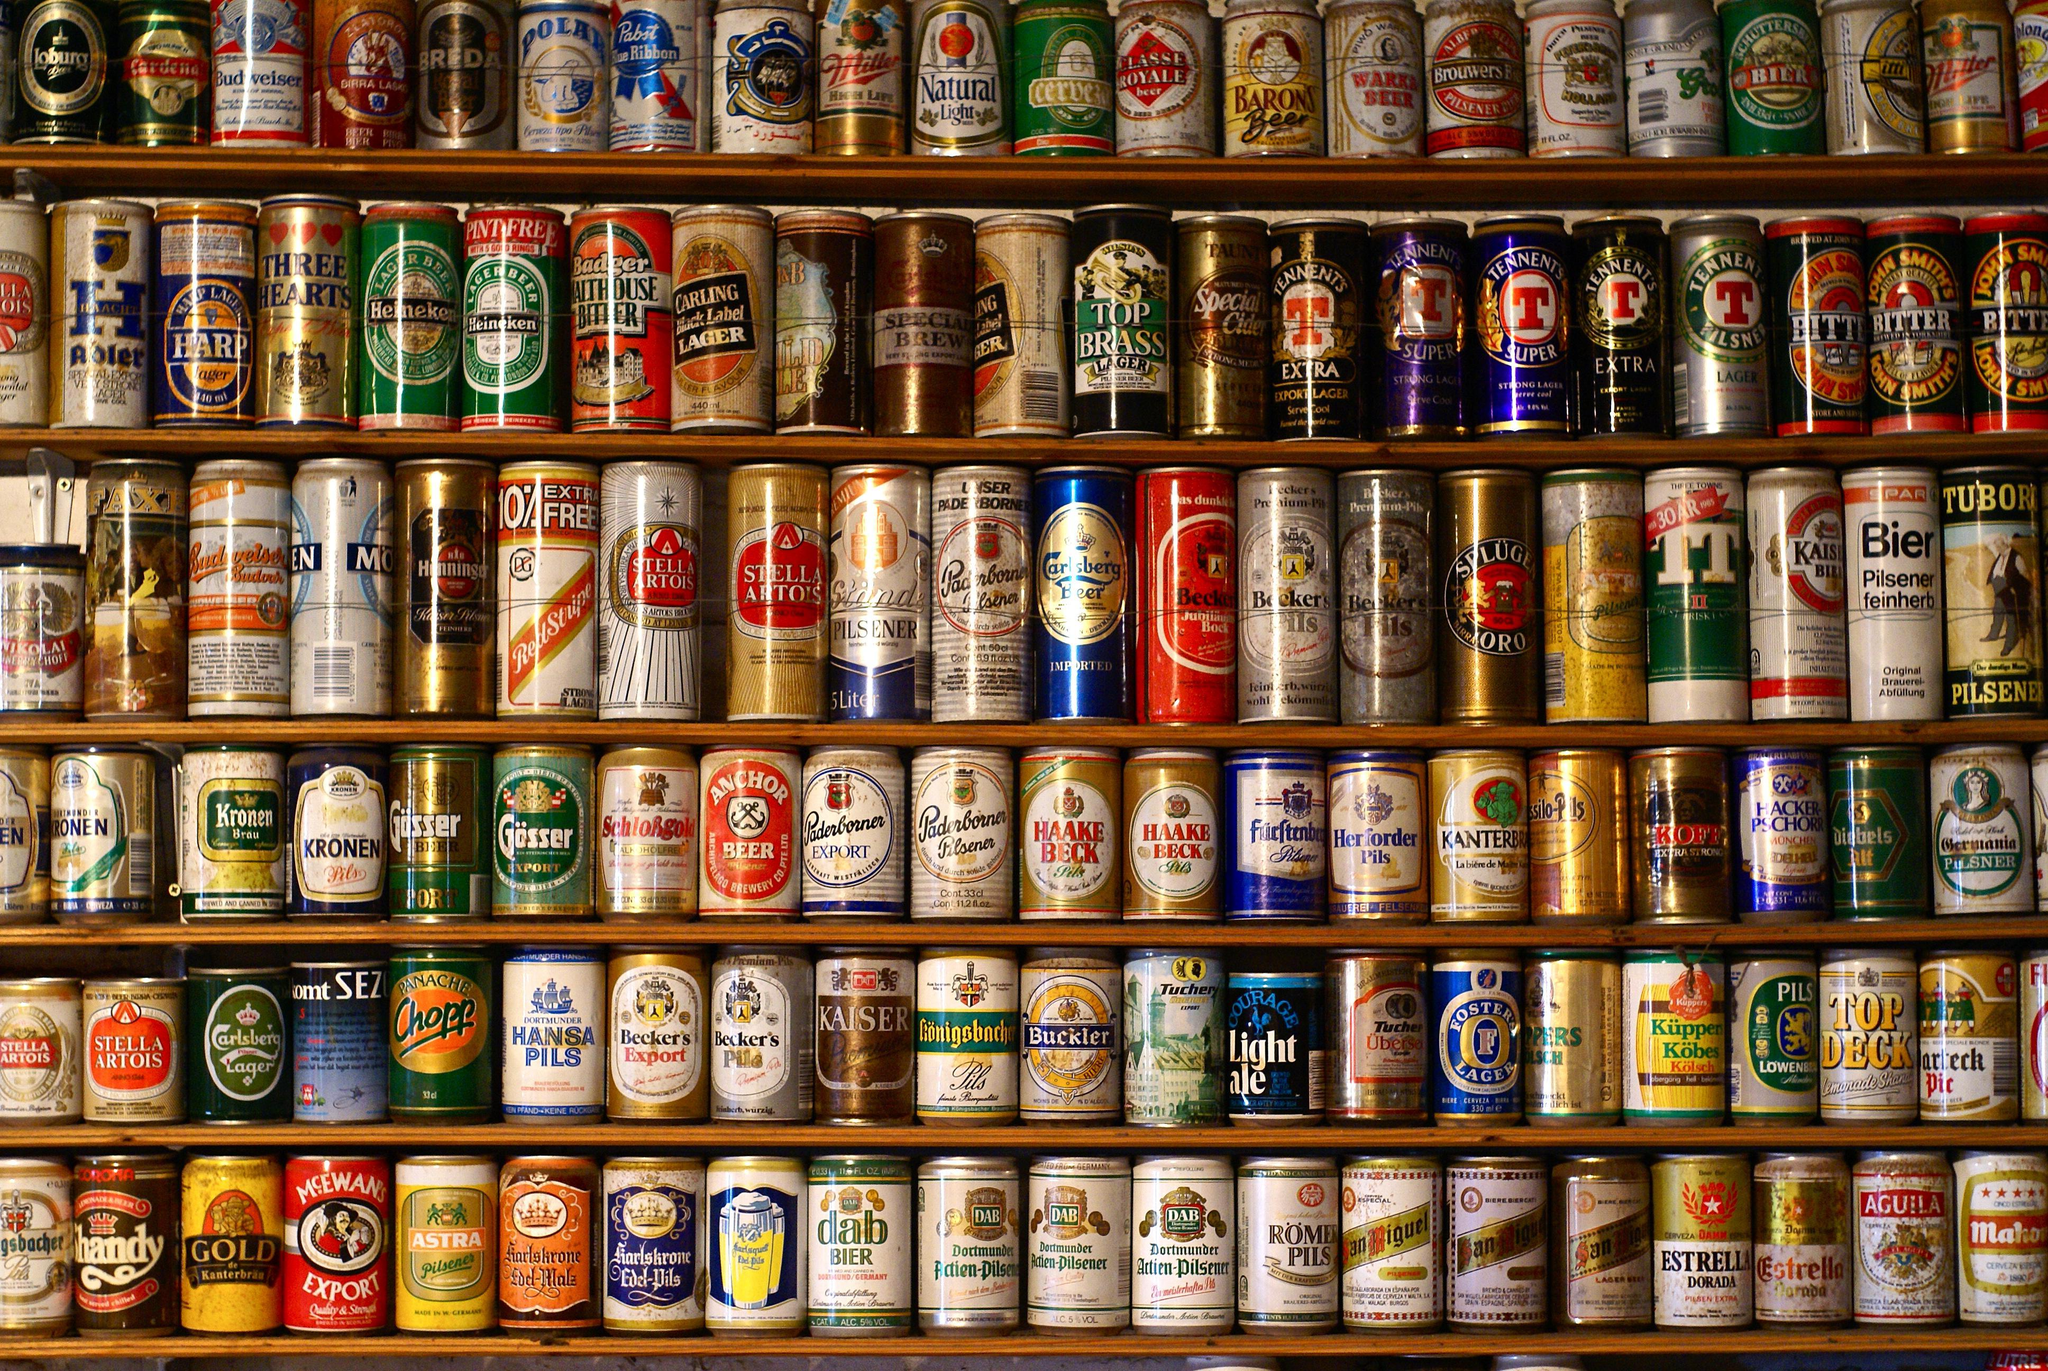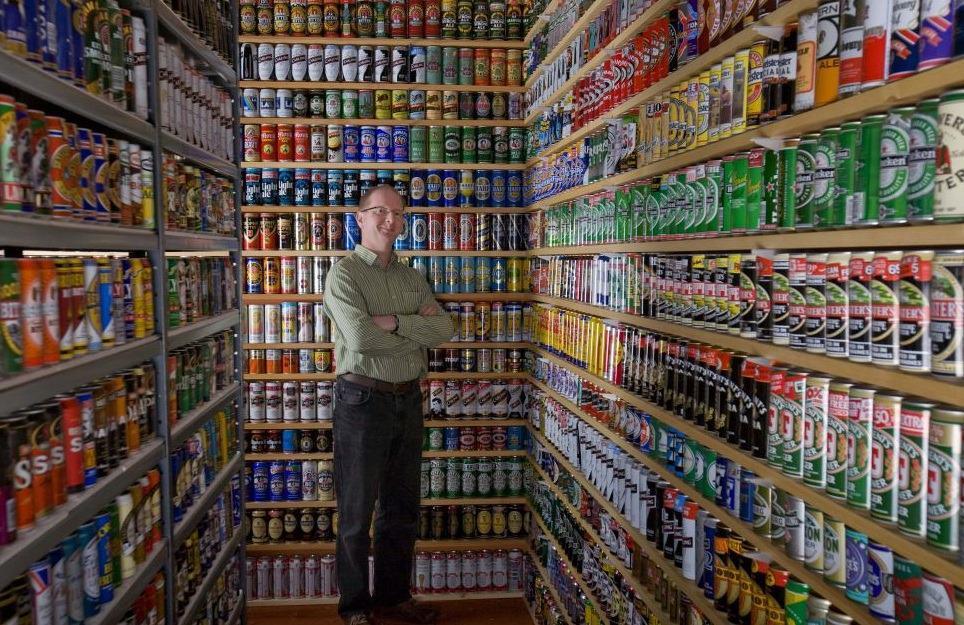The first image is the image on the left, the second image is the image on the right. Analyze the images presented: Is the assertion "All of the beer is on shelving." valid? Answer yes or no. Yes. 